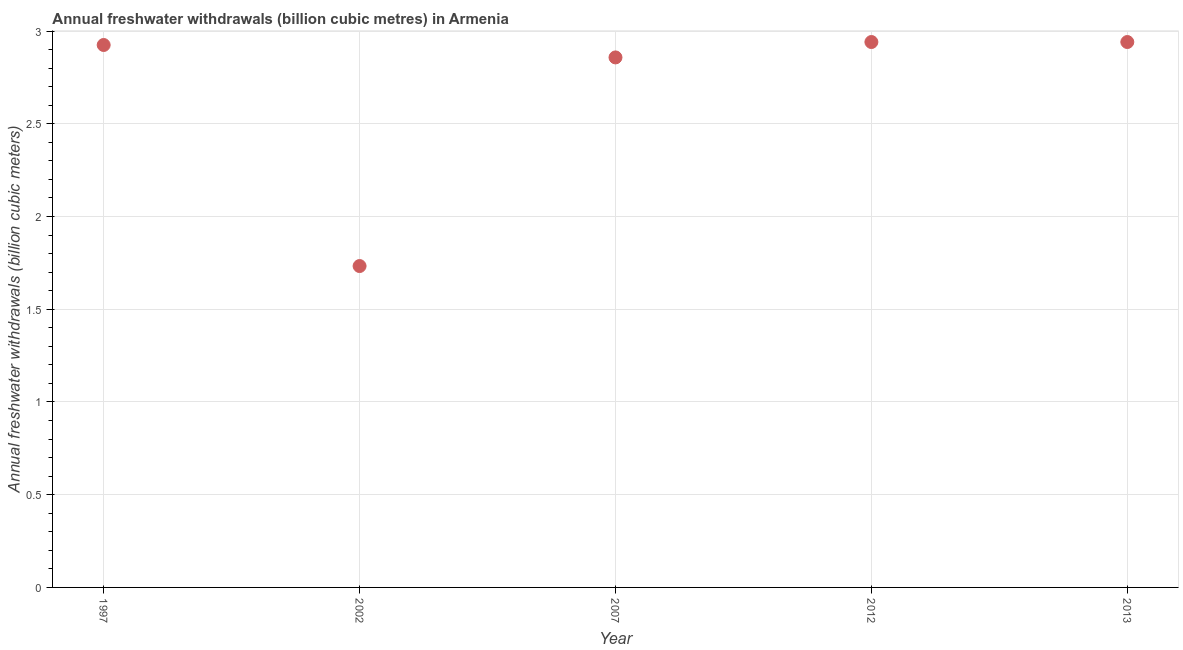What is the annual freshwater withdrawals in 2012?
Offer a very short reply. 2.94. Across all years, what is the maximum annual freshwater withdrawals?
Your response must be concise. 2.94. Across all years, what is the minimum annual freshwater withdrawals?
Offer a terse response. 1.73. What is the sum of the annual freshwater withdrawals?
Make the answer very short. 13.4. What is the difference between the annual freshwater withdrawals in 2007 and 2013?
Your answer should be compact. -0.08. What is the average annual freshwater withdrawals per year?
Make the answer very short. 2.68. What is the median annual freshwater withdrawals?
Offer a very short reply. 2.92. In how many years, is the annual freshwater withdrawals greater than 1 billion cubic meters?
Ensure brevity in your answer.  5. What is the ratio of the annual freshwater withdrawals in 2002 to that in 2007?
Provide a short and direct response. 0.61. Is the sum of the annual freshwater withdrawals in 2012 and 2013 greater than the maximum annual freshwater withdrawals across all years?
Make the answer very short. Yes. What is the difference between the highest and the lowest annual freshwater withdrawals?
Offer a terse response. 1.21. In how many years, is the annual freshwater withdrawals greater than the average annual freshwater withdrawals taken over all years?
Your response must be concise. 4. Does the annual freshwater withdrawals monotonically increase over the years?
Make the answer very short. No. How many dotlines are there?
Ensure brevity in your answer.  1. Does the graph contain grids?
Keep it short and to the point. Yes. What is the title of the graph?
Your answer should be very brief. Annual freshwater withdrawals (billion cubic metres) in Armenia. What is the label or title of the X-axis?
Keep it short and to the point. Year. What is the label or title of the Y-axis?
Ensure brevity in your answer.  Annual freshwater withdrawals (billion cubic meters). What is the Annual freshwater withdrawals (billion cubic meters) in 1997?
Your answer should be compact. 2.92. What is the Annual freshwater withdrawals (billion cubic meters) in 2002?
Give a very brief answer. 1.73. What is the Annual freshwater withdrawals (billion cubic meters) in 2007?
Give a very brief answer. 2.86. What is the Annual freshwater withdrawals (billion cubic meters) in 2012?
Make the answer very short. 2.94. What is the Annual freshwater withdrawals (billion cubic meters) in 2013?
Ensure brevity in your answer.  2.94. What is the difference between the Annual freshwater withdrawals (billion cubic meters) in 1997 and 2002?
Provide a short and direct response. 1.19. What is the difference between the Annual freshwater withdrawals (billion cubic meters) in 1997 and 2007?
Your answer should be compact. 0.07. What is the difference between the Annual freshwater withdrawals (billion cubic meters) in 1997 and 2012?
Provide a short and direct response. -0.02. What is the difference between the Annual freshwater withdrawals (billion cubic meters) in 1997 and 2013?
Your response must be concise. -0.02. What is the difference between the Annual freshwater withdrawals (billion cubic meters) in 2002 and 2007?
Ensure brevity in your answer.  -1.12. What is the difference between the Annual freshwater withdrawals (billion cubic meters) in 2002 and 2012?
Your response must be concise. -1.21. What is the difference between the Annual freshwater withdrawals (billion cubic meters) in 2002 and 2013?
Offer a very short reply. -1.21. What is the difference between the Annual freshwater withdrawals (billion cubic meters) in 2007 and 2012?
Make the answer very short. -0.08. What is the difference between the Annual freshwater withdrawals (billion cubic meters) in 2007 and 2013?
Ensure brevity in your answer.  -0.08. What is the ratio of the Annual freshwater withdrawals (billion cubic meters) in 1997 to that in 2002?
Make the answer very short. 1.69. What is the ratio of the Annual freshwater withdrawals (billion cubic meters) in 1997 to that in 2007?
Keep it short and to the point. 1.02. What is the ratio of the Annual freshwater withdrawals (billion cubic meters) in 2002 to that in 2007?
Make the answer very short. 0.61. What is the ratio of the Annual freshwater withdrawals (billion cubic meters) in 2002 to that in 2012?
Keep it short and to the point. 0.59. What is the ratio of the Annual freshwater withdrawals (billion cubic meters) in 2002 to that in 2013?
Provide a short and direct response. 0.59. What is the ratio of the Annual freshwater withdrawals (billion cubic meters) in 2012 to that in 2013?
Ensure brevity in your answer.  1. 